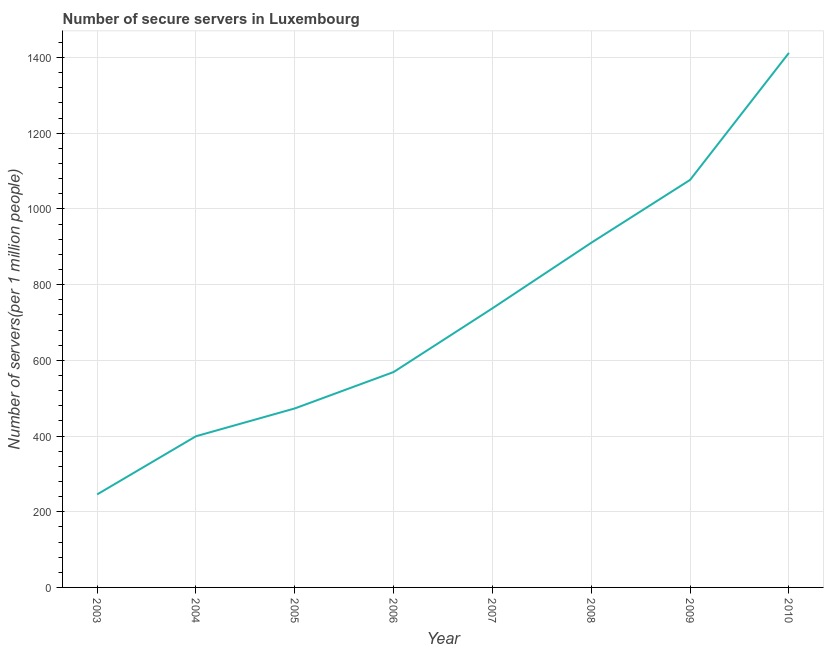What is the number of secure internet servers in 2004?
Your response must be concise. 399.48. Across all years, what is the maximum number of secure internet servers?
Provide a succinct answer. 1412.36. Across all years, what is the minimum number of secure internet servers?
Offer a very short reply. 245.78. What is the sum of the number of secure internet servers?
Provide a succinct answer. 5824.68. What is the difference between the number of secure internet servers in 2005 and 2008?
Your answer should be compact. -437.71. What is the average number of secure internet servers per year?
Keep it short and to the point. 728.08. What is the median number of secure internet servers?
Offer a very short reply. 653.33. In how many years, is the number of secure internet servers greater than 120 ?
Your answer should be very brief. 8. Do a majority of the years between 2009 and 2007 (inclusive) have number of secure internet servers greater than 480 ?
Keep it short and to the point. No. What is the ratio of the number of secure internet servers in 2006 to that in 2010?
Give a very brief answer. 0.4. Is the number of secure internet servers in 2003 less than that in 2009?
Provide a short and direct response. Yes. What is the difference between the highest and the second highest number of secure internet servers?
Provide a succinct answer. 335.59. Is the sum of the number of secure internet servers in 2007 and 2009 greater than the maximum number of secure internet servers across all years?
Give a very brief answer. Yes. What is the difference between the highest and the lowest number of secure internet servers?
Provide a succinct answer. 1166.58. Does the number of secure internet servers monotonically increase over the years?
Provide a succinct answer. Yes. How many years are there in the graph?
Provide a succinct answer. 8. What is the difference between two consecutive major ticks on the Y-axis?
Provide a short and direct response. 200. Are the values on the major ticks of Y-axis written in scientific E-notation?
Your answer should be very brief. No. What is the title of the graph?
Your answer should be very brief. Number of secure servers in Luxembourg. What is the label or title of the Y-axis?
Offer a very short reply. Number of servers(per 1 million people). What is the Number of servers(per 1 million people) of 2003?
Offer a very short reply. 245.78. What is the Number of servers(per 1 million people) of 2004?
Make the answer very short. 399.48. What is the Number of servers(per 1 million people) in 2005?
Offer a terse response. 472.96. What is the Number of servers(per 1 million people) in 2006?
Your answer should be very brief. 569.15. What is the Number of servers(per 1 million people) of 2007?
Provide a succinct answer. 737.51. What is the Number of servers(per 1 million people) in 2008?
Give a very brief answer. 910.67. What is the Number of servers(per 1 million people) of 2009?
Offer a terse response. 1076.77. What is the Number of servers(per 1 million people) in 2010?
Offer a terse response. 1412.36. What is the difference between the Number of servers(per 1 million people) in 2003 and 2004?
Your answer should be very brief. -153.7. What is the difference between the Number of servers(per 1 million people) in 2003 and 2005?
Ensure brevity in your answer.  -227.18. What is the difference between the Number of servers(per 1 million people) in 2003 and 2006?
Your answer should be very brief. -323.37. What is the difference between the Number of servers(per 1 million people) in 2003 and 2007?
Provide a succinct answer. -491.73. What is the difference between the Number of servers(per 1 million people) in 2003 and 2008?
Provide a succinct answer. -664.9. What is the difference between the Number of servers(per 1 million people) in 2003 and 2009?
Offer a very short reply. -831. What is the difference between the Number of servers(per 1 million people) in 2003 and 2010?
Give a very brief answer. -1166.58. What is the difference between the Number of servers(per 1 million people) in 2004 and 2005?
Make the answer very short. -73.48. What is the difference between the Number of servers(per 1 million people) in 2004 and 2006?
Your answer should be very brief. -169.67. What is the difference between the Number of servers(per 1 million people) in 2004 and 2007?
Provide a short and direct response. -338.03. What is the difference between the Number of servers(per 1 million people) in 2004 and 2008?
Give a very brief answer. -511.19. What is the difference between the Number of servers(per 1 million people) in 2004 and 2009?
Provide a short and direct response. -677.29. What is the difference between the Number of servers(per 1 million people) in 2004 and 2010?
Offer a terse response. -1012.88. What is the difference between the Number of servers(per 1 million people) in 2005 and 2006?
Your response must be concise. -96.19. What is the difference between the Number of servers(per 1 million people) in 2005 and 2007?
Your response must be concise. -264.55. What is the difference between the Number of servers(per 1 million people) in 2005 and 2008?
Your answer should be compact. -437.71. What is the difference between the Number of servers(per 1 million people) in 2005 and 2009?
Provide a short and direct response. -603.82. What is the difference between the Number of servers(per 1 million people) in 2005 and 2010?
Keep it short and to the point. -939.4. What is the difference between the Number of servers(per 1 million people) in 2006 and 2007?
Provide a succinct answer. -168.36. What is the difference between the Number of servers(per 1 million people) in 2006 and 2008?
Provide a short and direct response. -341.53. What is the difference between the Number of servers(per 1 million people) in 2006 and 2009?
Make the answer very short. -507.63. What is the difference between the Number of servers(per 1 million people) in 2006 and 2010?
Offer a terse response. -843.21. What is the difference between the Number of servers(per 1 million people) in 2007 and 2008?
Make the answer very short. -173.16. What is the difference between the Number of servers(per 1 million people) in 2007 and 2009?
Offer a terse response. -339.26. What is the difference between the Number of servers(per 1 million people) in 2007 and 2010?
Give a very brief answer. -674.85. What is the difference between the Number of servers(per 1 million people) in 2008 and 2009?
Your response must be concise. -166.1. What is the difference between the Number of servers(per 1 million people) in 2008 and 2010?
Give a very brief answer. -501.69. What is the difference between the Number of servers(per 1 million people) in 2009 and 2010?
Provide a succinct answer. -335.59. What is the ratio of the Number of servers(per 1 million people) in 2003 to that in 2004?
Ensure brevity in your answer.  0.61. What is the ratio of the Number of servers(per 1 million people) in 2003 to that in 2005?
Give a very brief answer. 0.52. What is the ratio of the Number of servers(per 1 million people) in 2003 to that in 2006?
Your answer should be very brief. 0.43. What is the ratio of the Number of servers(per 1 million people) in 2003 to that in 2007?
Offer a terse response. 0.33. What is the ratio of the Number of servers(per 1 million people) in 2003 to that in 2008?
Give a very brief answer. 0.27. What is the ratio of the Number of servers(per 1 million people) in 2003 to that in 2009?
Give a very brief answer. 0.23. What is the ratio of the Number of servers(per 1 million people) in 2003 to that in 2010?
Your response must be concise. 0.17. What is the ratio of the Number of servers(per 1 million people) in 2004 to that in 2005?
Provide a succinct answer. 0.84. What is the ratio of the Number of servers(per 1 million people) in 2004 to that in 2006?
Your answer should be compact. 0.7. What is the ratio of the Number of servers(per 1 million people) in 2004 to that in 2007?
Your response must be concise. 0.54. What is the ratio of the Number of servers(per 1 million people) in 2004 to that in 2008?
Your answer should be compact. 0.44. What is the ratio of the Number of servers(per 1 million people) in 2004 to that in 2009?
Keep it short and to the point. 0.37. What is the ratio of the Number of servers(per 1 million people) in 2004 to that in 2010?
Your answer should be compact. 0.28. What is the ratio of the Number of servers(per 1 million people) in 2005 to that in 2006?
Provide a short and direct response. 0.83. What is the ratio of the Number of servers(per 1 million people) in 2005 to that in 2007?
Provide a succinct answer. 0.64. What is the ratio of the Number of servers(per 1 million people) in 2005 to that in 2008?
Make the answer very short. 0.52. What is the ratio of the Number of servers(per 1 million people) in 2005 to that in 2009?
Your answer should be compact. 0.44. What is the ratio of the Number of servers(per 1 million people) in 2005 to that in 2010?
Keep it short and to the point. 0.34. What is the ratio of the Number of servers(per 1 million people) in 2006 to that in 2007?
Your answer should be compact. 0.77. What is the ratio of the Number of servers(per 1 million people) in 2006 to that in 2008?
Provide a succinct answer. 0.62. What is the ratio of the Number of servers(per 1 million people) in 2006 to that in 2009?
Your answer should be compact. 0.53. What is the ratio of the Number of servers(per 1 million people) in 2006 to that in 2010?
Give a very brief answer. 0.4. What is the ratio of the Number of servers(per 1 million people) in 2007 to that in 2008?
Ensure brevity in your answer.  0.81. What is the ratio of the Number of servers(per 1 million people) in 2007 to that in 2009?
Provide a succinct answer. 0.69. What is the ratio of the Number of servers(per 1 million people) in 2007 to that in 2010?
Your answer should be very brief. 0.52. What is the ratio of the Number of servers(per 1 million people) in 2008 to that in 2009?
Provide a succinct answer. 0.85. What is the ratio of the Number of servers(per 1 million people) in 2008 to that in 2010?
Keep it short and to the point. 0.65. What is the ratio of the Number of servers(per 1 million people) in 2009 to that in 2010?
Ensure brevity in your answer.  0.76. 